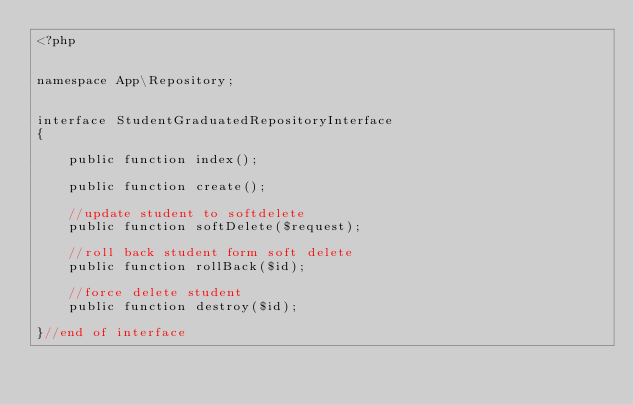Convert code to text. <code><loc_0><loc_0><loc_500><loc_500><_PHP_><?php


namespace App\Repository;


interface StudentGraduatedRepositoryInterface
{

    public function index();

    public function create();

    //update student to softdelete
    public function softDelete($request);

    //roll back student form soft delete
    public function rollBack($id);

    //force delete student
    public function destroy($id);

}//end of interface
</code> 